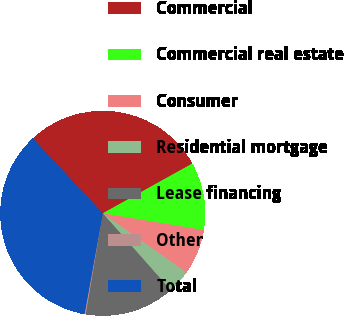Convert chart to OTSL. <chart><loc_0><loc_0><loc_500><loc_500><pie_chart><fcel>Commercial<fcel>Commercial real estate<fcel>Consumer<fcel>Residential mortgage<fcel>Lease financing<fcel>Other<fcel>Total<nl><fcel>28.88%<fcel>10.69%<fcel>7.18%<fcel>3.68%<fcel>14.19%<fcel>0.18%<fcel>35.2%<nl></chart> 